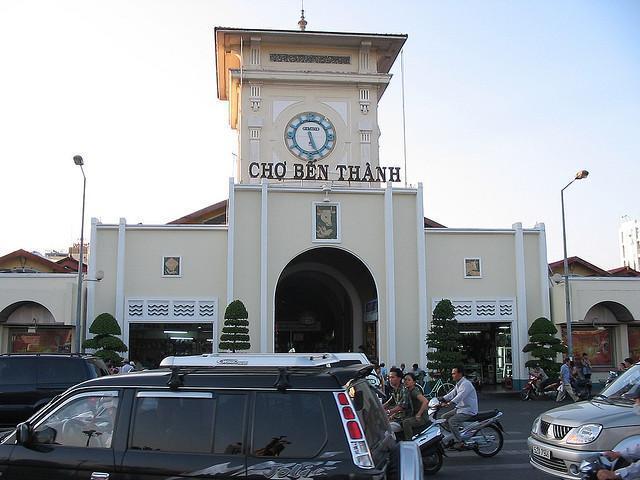How many cars can be seen?
Give a very brief answer. 3. 